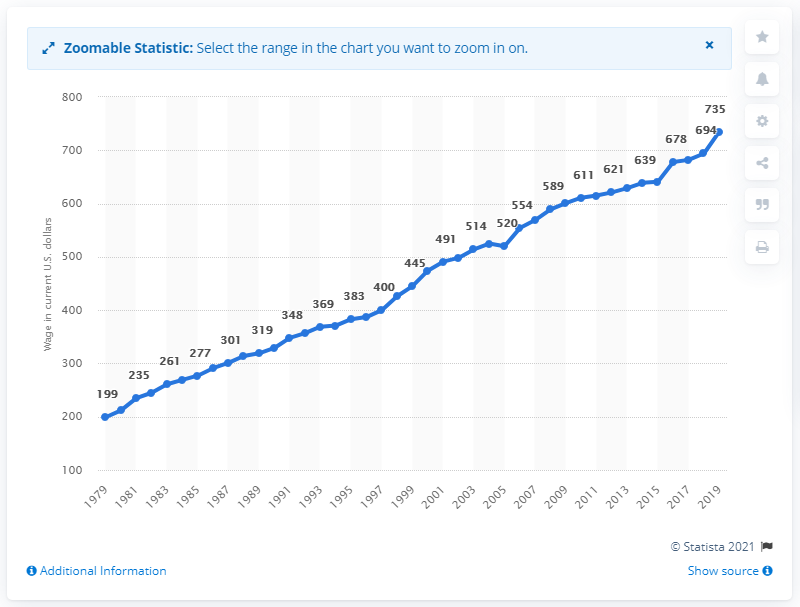Outline some significant characteristics in this image. In 1979, the median weekly earnings of a Black full-time employee in the United States was $218, while in 1999 it was $276. According to data from 2019, the median weekly earnings of an African American working full-time was $735. 